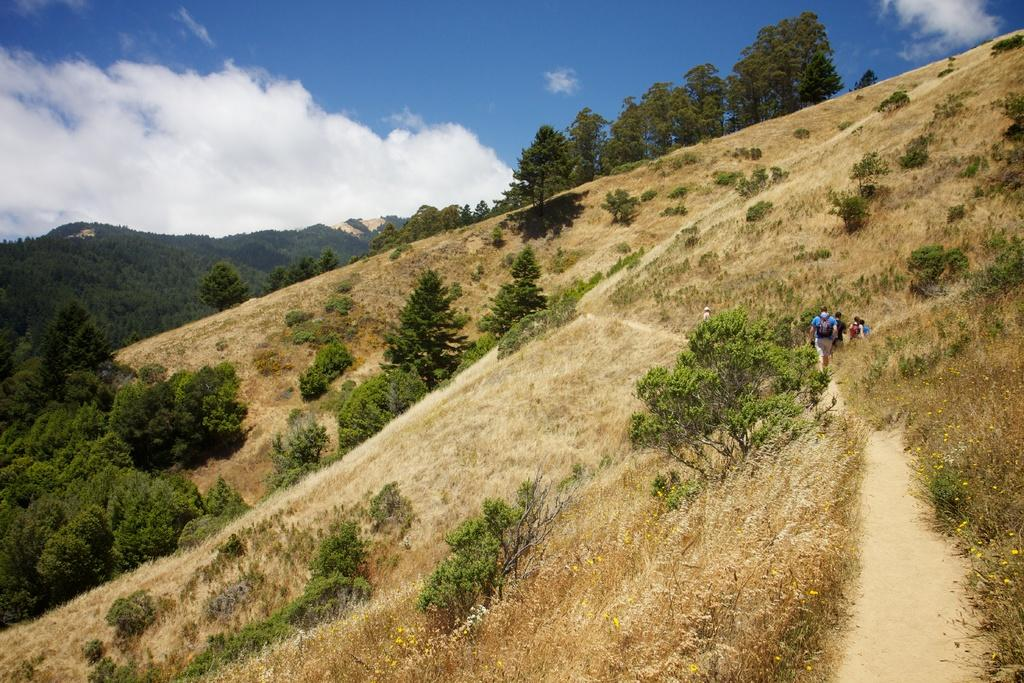What can be seen in the image? There are people standing in the image, along with hills, trees, grass, and plants. What is visible in the background of the image? The sky is visible in the background of the image. How many pockets can be seen on the people in the image? There is no information about pockets on the people in the image, so it cannot be determined. Can you tell me how many times the people in the image sneeze? There is no information about sneezing in the image, so it cannot be determined. 